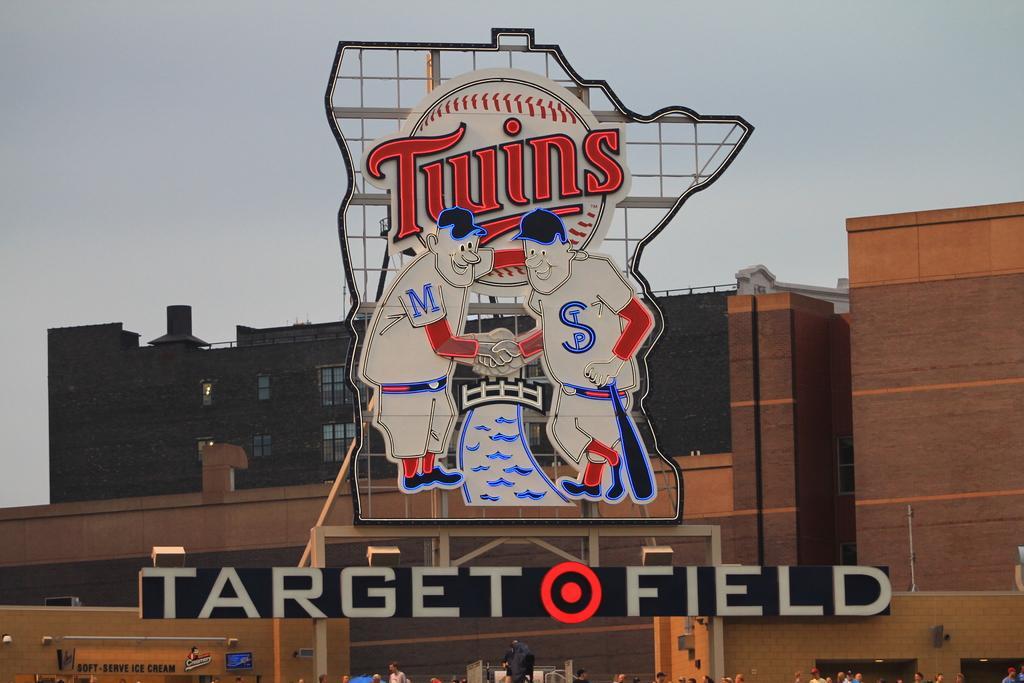Please provide a concise description of this image. In this picture we can see a name board, hoarding, group of people, some objects, building with windows and in the background we can see the sky. 